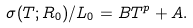Convert formula to latex. <formula><loc_0><loc_0><loc_500><loc_500>\sigma ( T ; R _ { 0 } ) / L _ { 0 } = B T ^ { p } + A .</formula> 